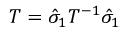Convert formula to latex. <formula><loc_0><loc_0><loc_500><loc_500>T = \hat { \sigma } _ { 1 } T ^ { - 1 } \hat { \sigma } _ { 1 }</formula> 